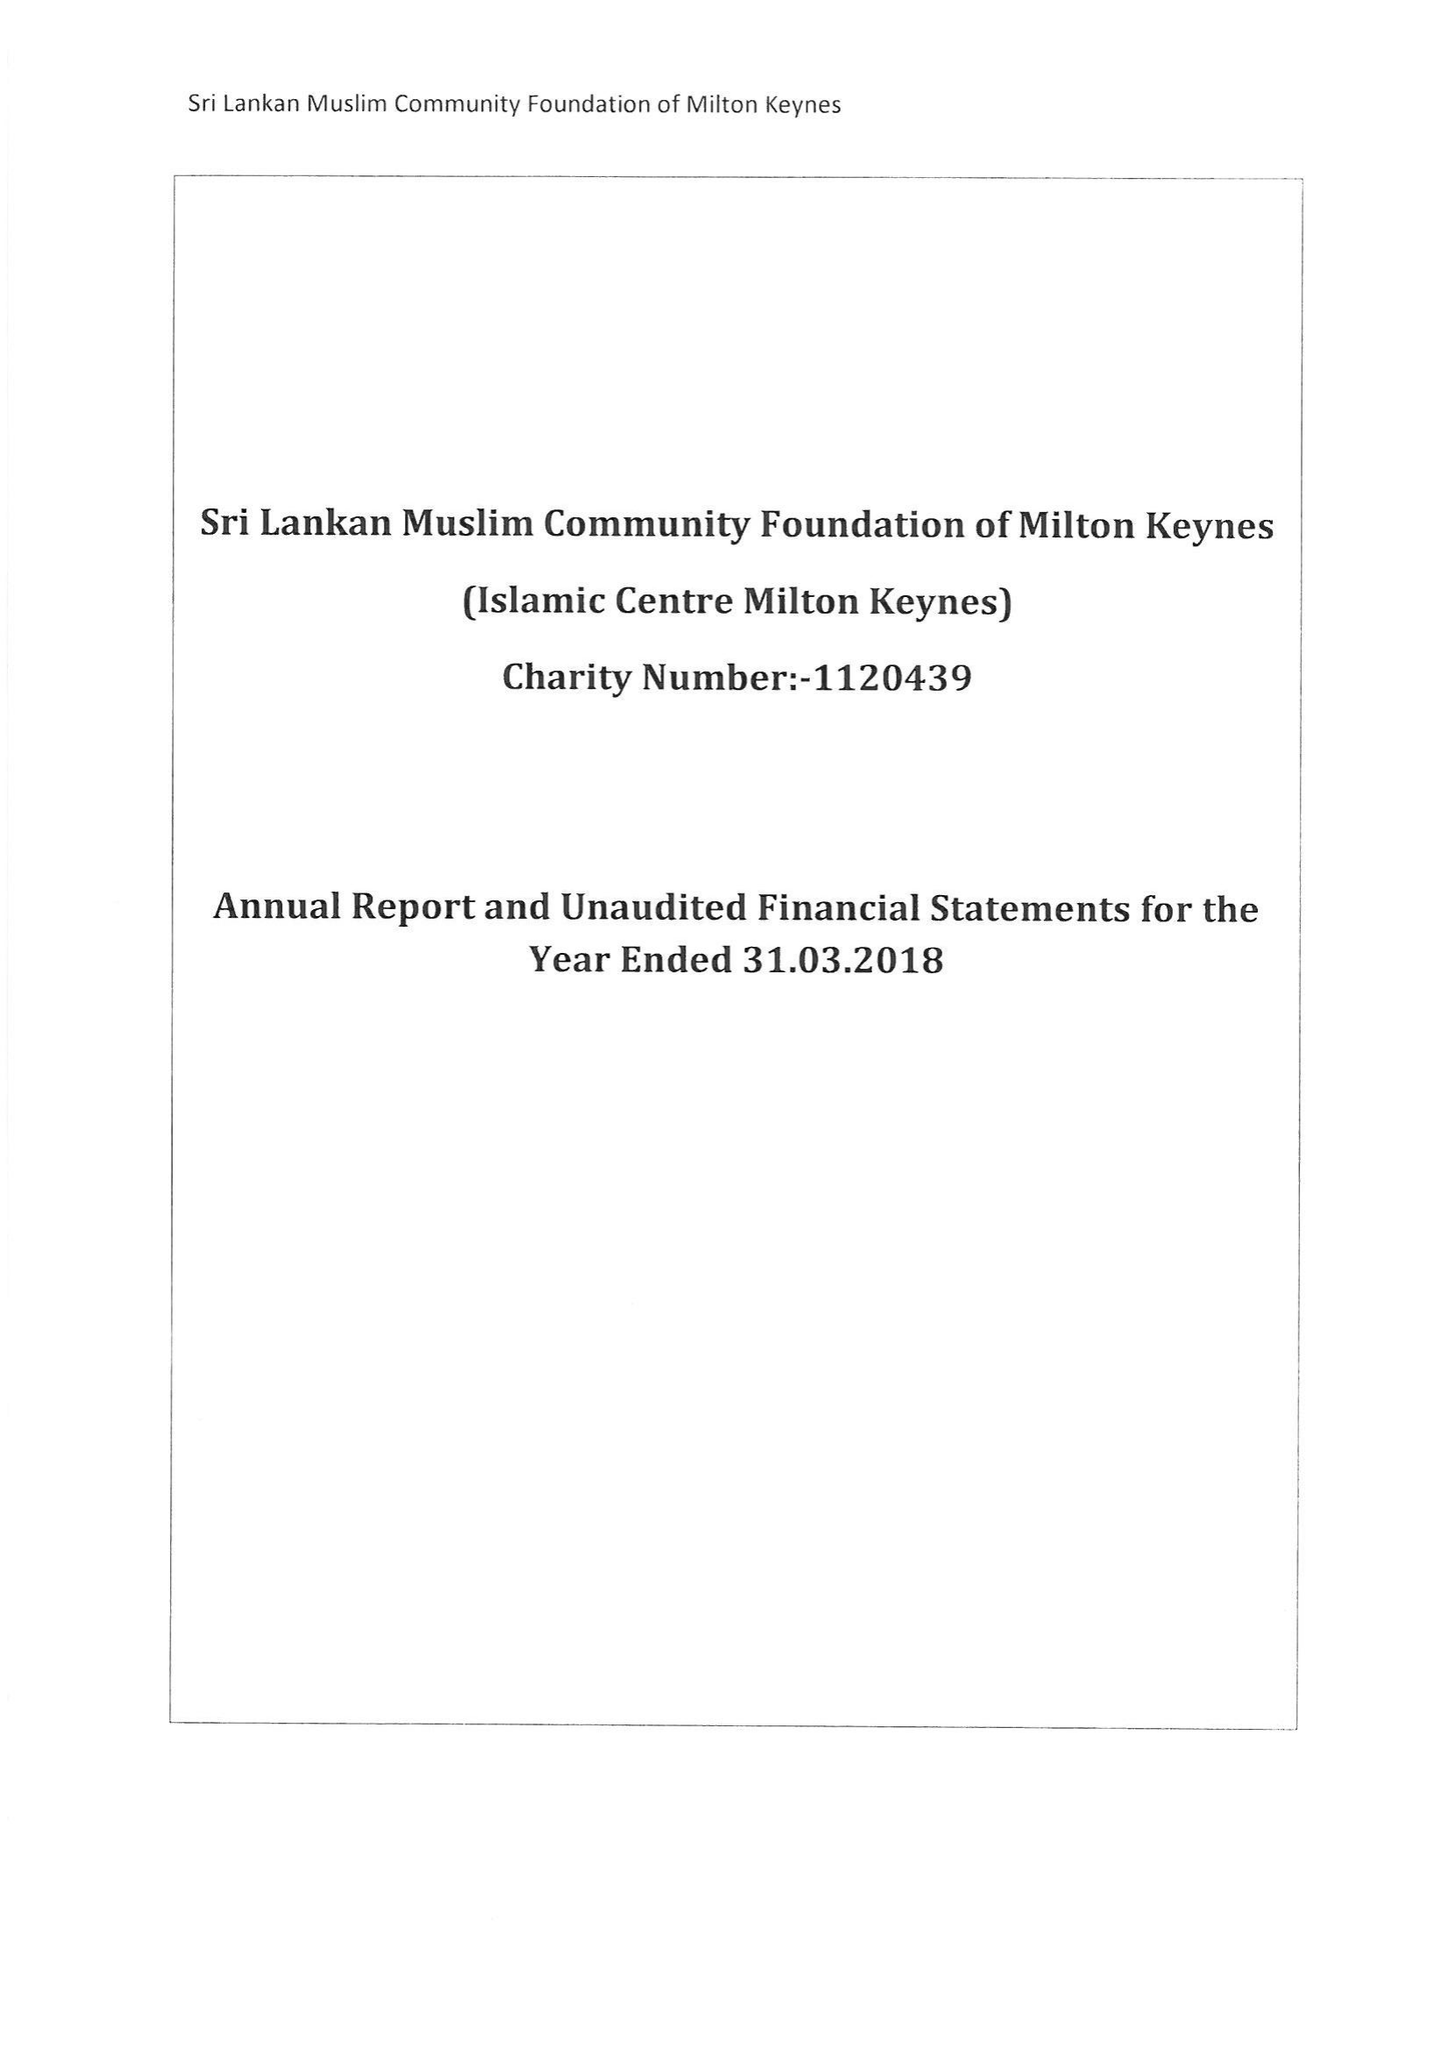What is the value for the report_date?
Answer the question using a single word or phrase. 2018-03-31 